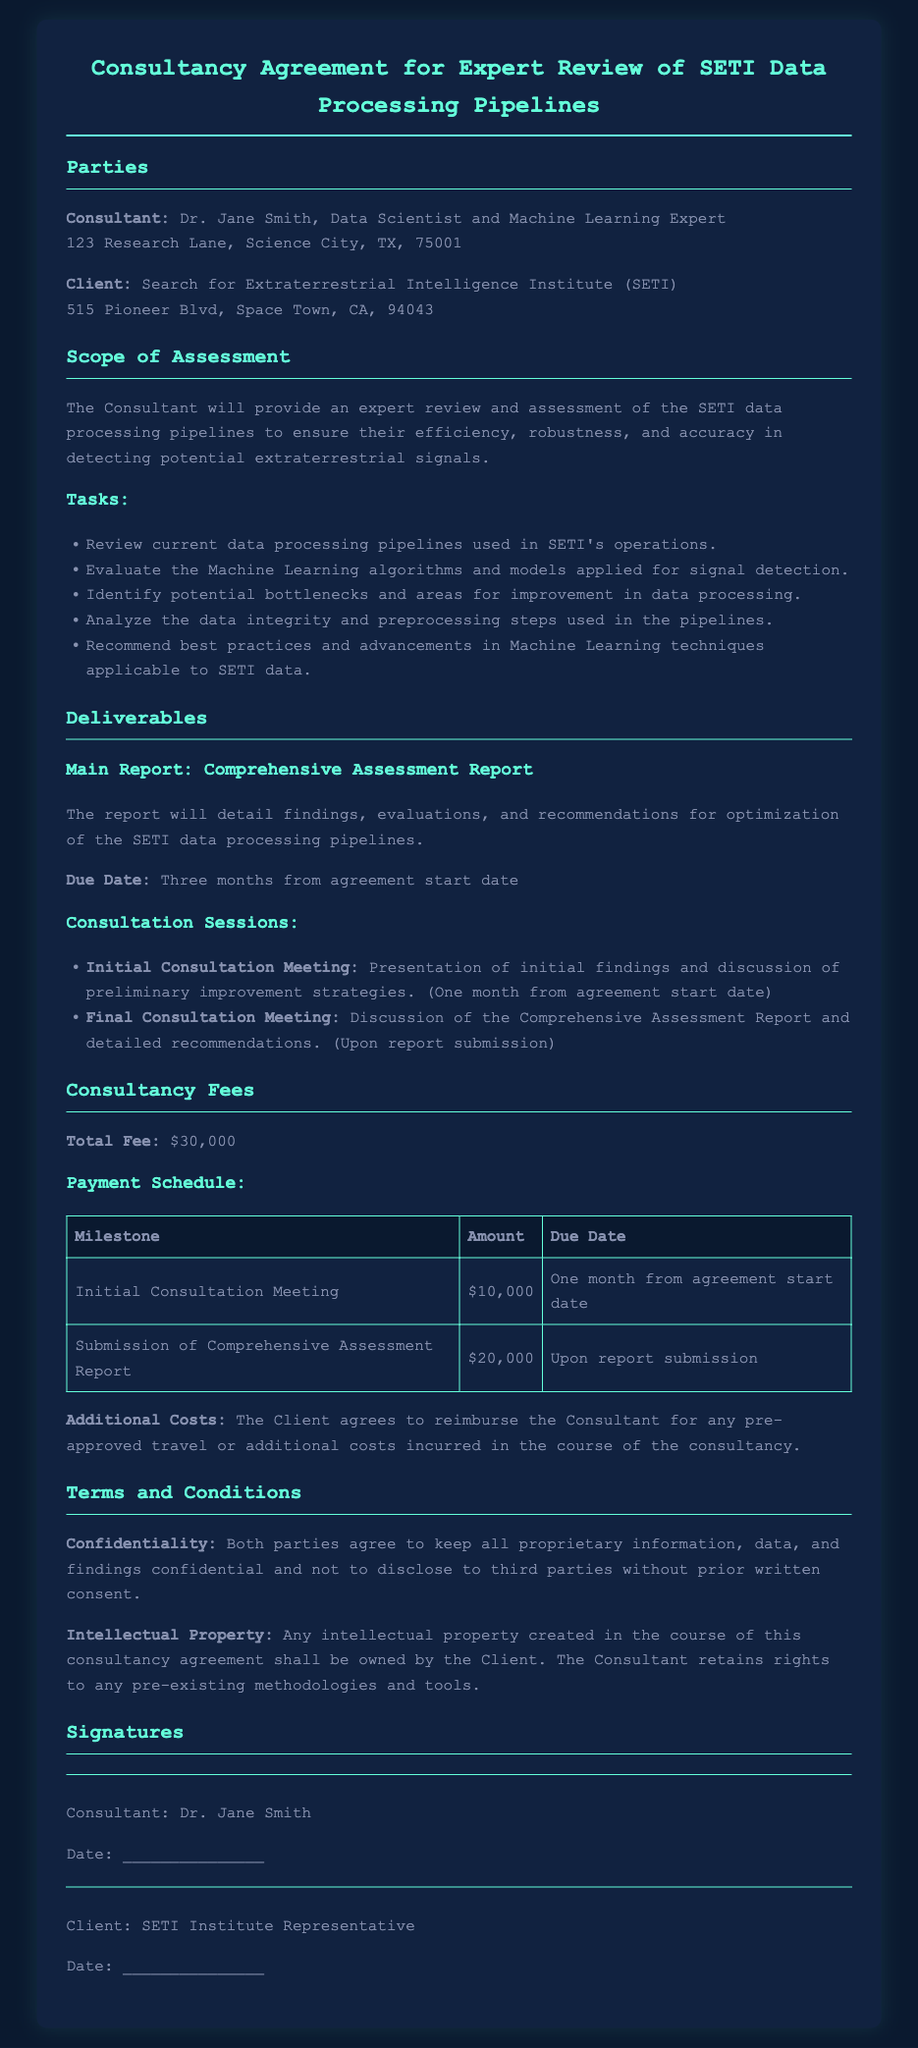What is the name of the Consultant? The Consultant is Dr. Jane Smith, as stated at the beginning of the document.
Answer: Dr. Jane Smith What is the total consultancy fee? The total fee is specified in the fees section of the document as $30,000.
Answer: $30,000 When is the due date for the Final Consultation Meeting? The Final Consultation Meeting is scheduled for upon submission of the Comprehensive Assessment Report, as indicated in the deliverables section.
Answer: Upon report submission What are the payment milestones for the consultancy fees? The payment schedule includes two milestones: Initial Consultation Meeting and Submission of Comprehensive Assessment Report, detailed in the fees section.
Answer: Initial Consultation Meeting, Submission of Comprehensive Assessment Report What type of intellectual property does the Consultant retain rights to? The document specifies that the Consultant retains rights to any pre-existing methodologies and tools.
Answer: Pre-existing methodologies and tools What will the Comprehensive Assessment Report include? The report will detail findings, evaluations, and recommendations for optimization of the SETI data processing pipelines, as outlined in the deliverables.
Answer: Findings, evaluations, recommendations How long after the agreement starts is the Comprehensive Assessment Report due? The due date for the Comprehensive Assessment Report is three months from the agreement start date, according to the deliverables section.
Answer: Three months What is the address of the Client? The address of the Client, SETI Institute, is provided as 515 Pioneer Blvd, Space Town, CA, 94043.
Answer: 515 Pioneer Blvd, Space Town, CA, 94043 